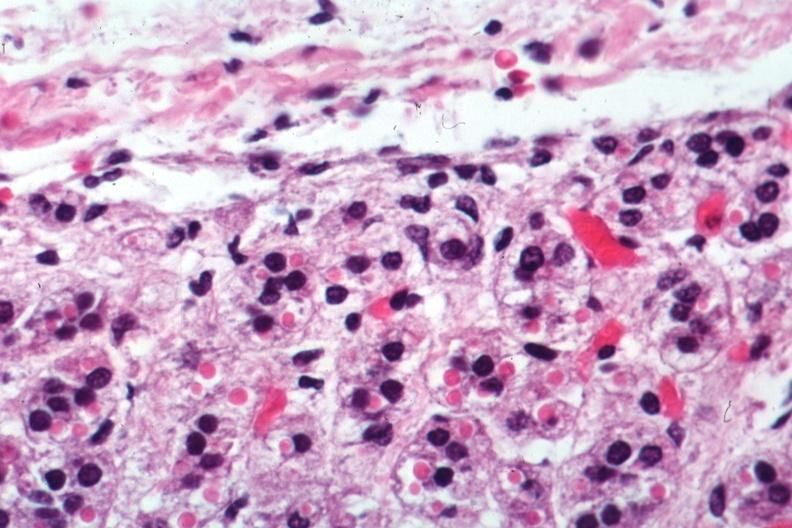what is present?
Answer the question using a single word or phrase. Endocrine 